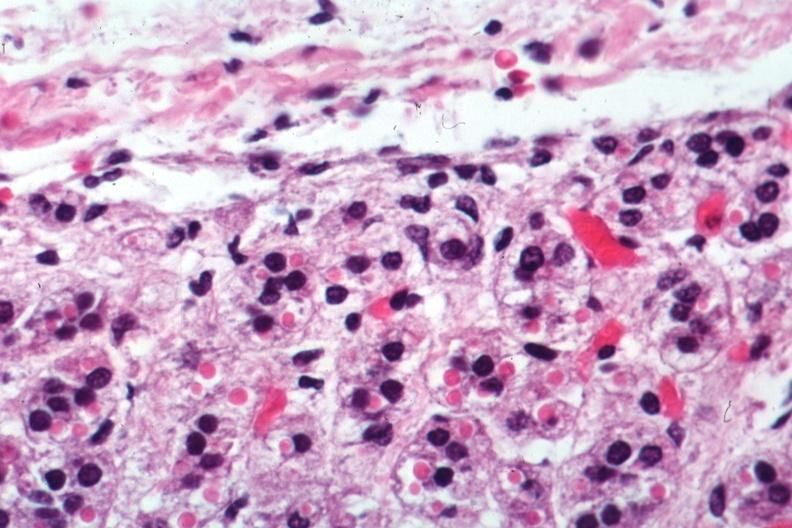what is present?
Answer the question using a single word or phrase. Endocrine 